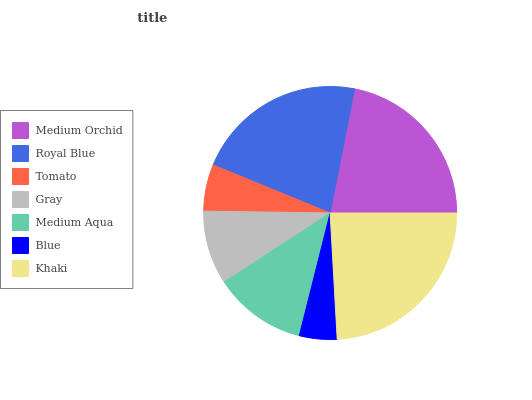Is Blue the minimum?
Answer yes or no. Yes. Is Khaki the maximum?
Answer yes or no. Yes. Is Royal Blue the minimum?
Answer yes or no. No. Is Royal Blue the maximum?
Answer yes or no. No. Is Medium Orchid greater than Royal Blue?
Answer yes or no. Yes. Is Royal Blue less than Medium Orchid?
Answer yes or no. Yes. Is Royal Blue greater than Medium Orchid?
Answer yes or no. No. Is Medium Orchid less than Royal Blue?
Answer yes or no. No. Is Medium Aqua the high median?
Answer yes or no. Yes. Is Medium Aqua the low median?
Answer yes or no. Yes. Is Royal Blue the high median?
Answer yes or no. No. Is Blue the low median?
Answer yes or no. No. 